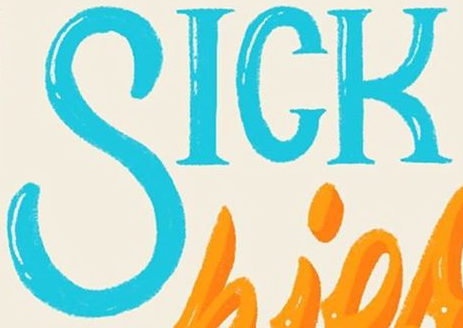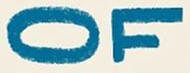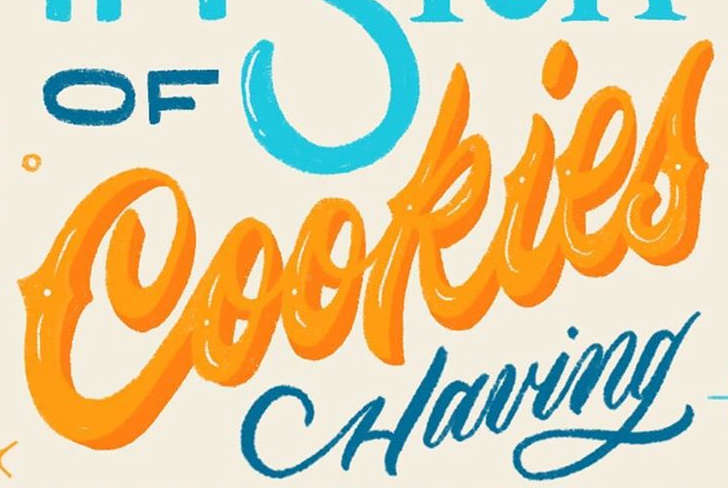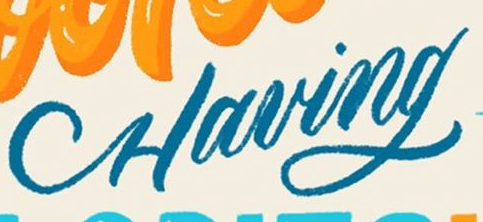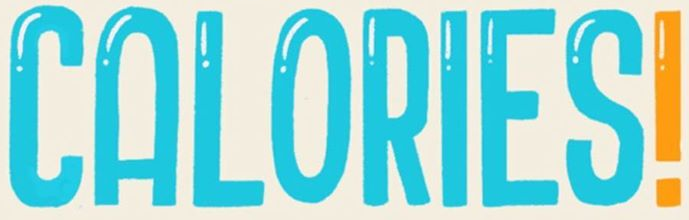What text is displayed in these images sequentially, separated by a semicolon? SICK; OF; Cookies; Having; CALORIES! 